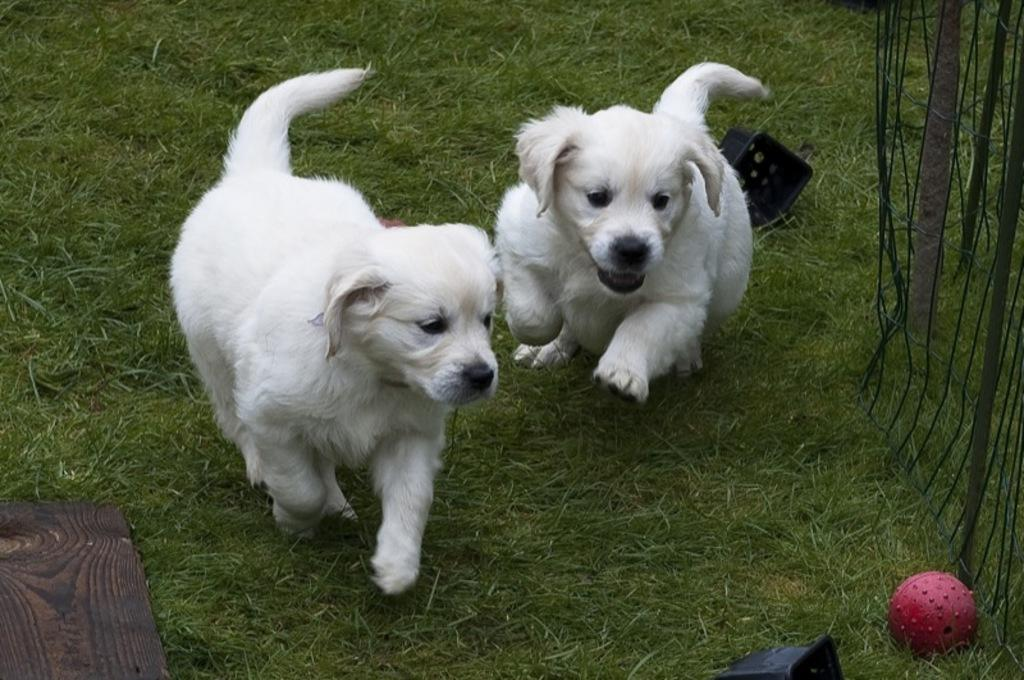What type of surface is visible in the picture? There is ground in the picture. How many puppies can be seen in the picture? There are two puppies in the picture. What are the puppies doing in the picture? The puppies are playing with a ball. Where is the rat hiding in the picture? There is no rat present in the picture; it only features two puppies playing with a ball. 